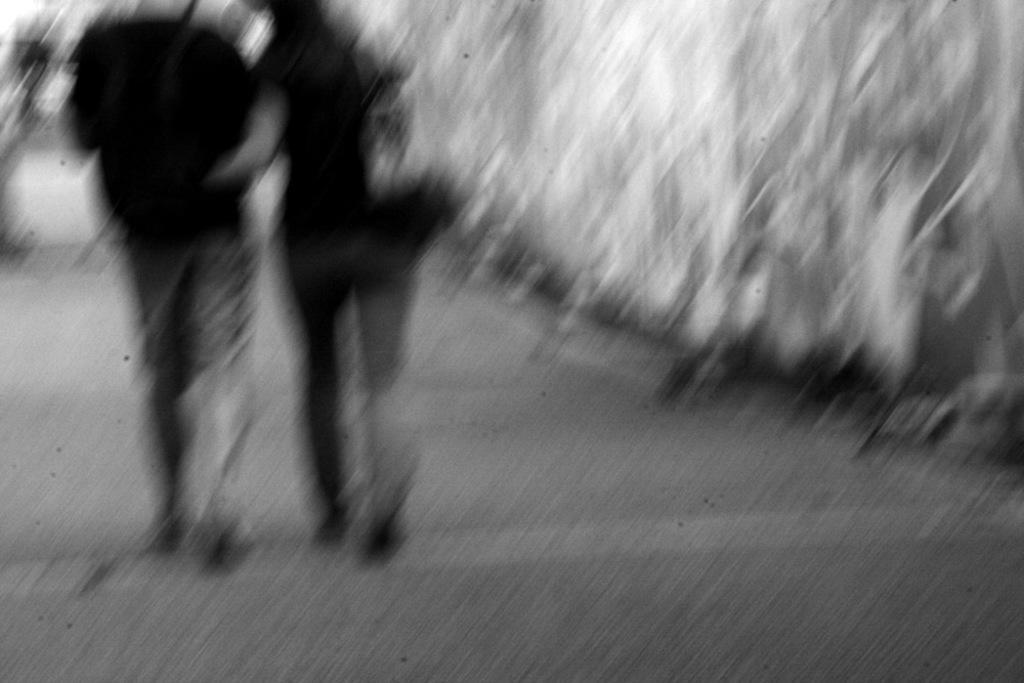Describe this image in one or two sentences. In this image we can see black and white picture of two persons walking on the ground. 